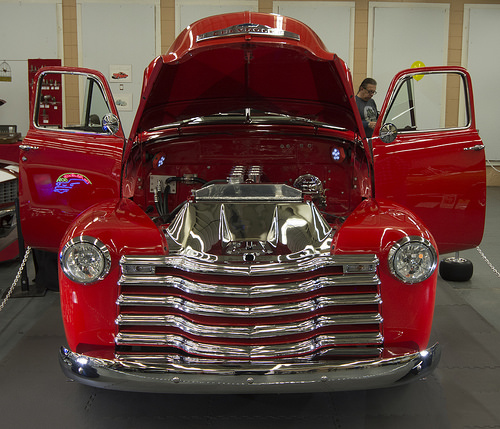<image>
Is there a bumper in front of the yellow balloon? Yes. The bumper is positioned in front of the yellow balloon, appearing closer to the camera viewpoint. 